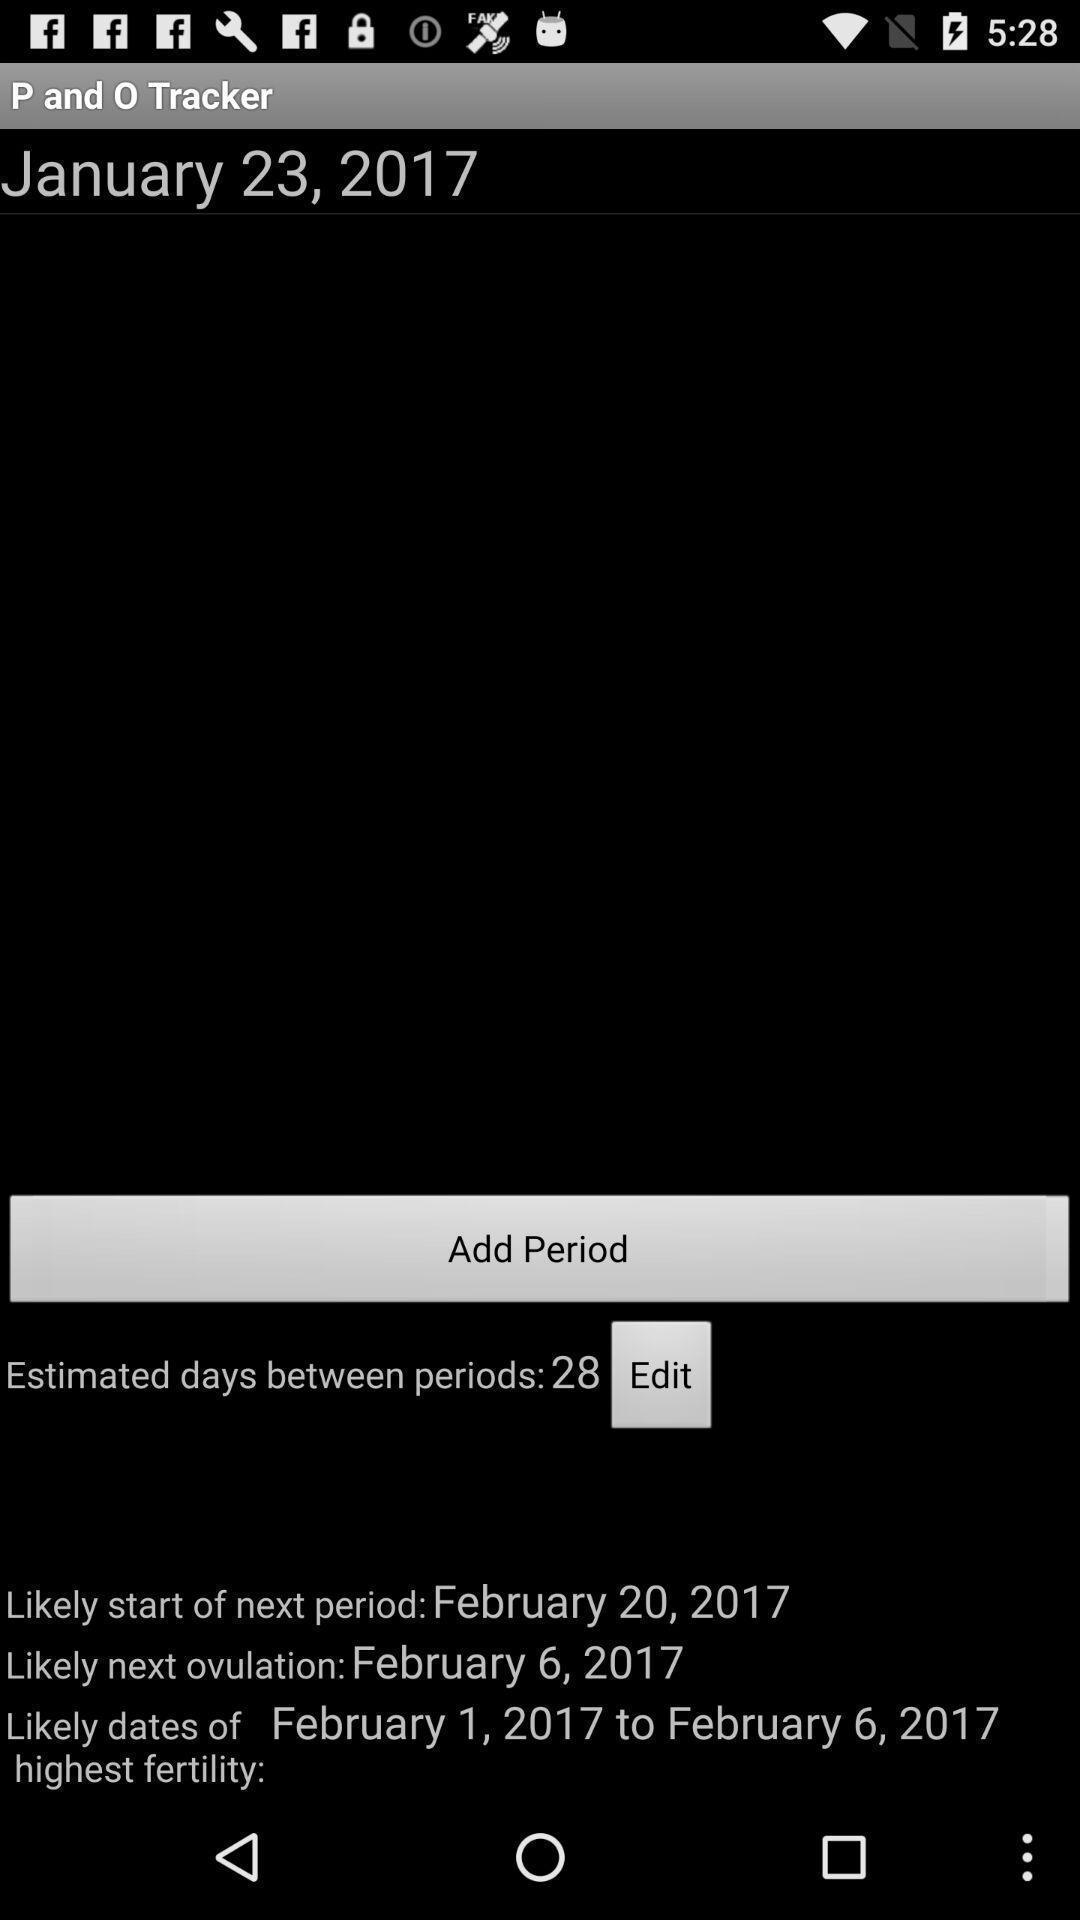What details can you identify in this image? Screen displaying the page of a tracker app. 